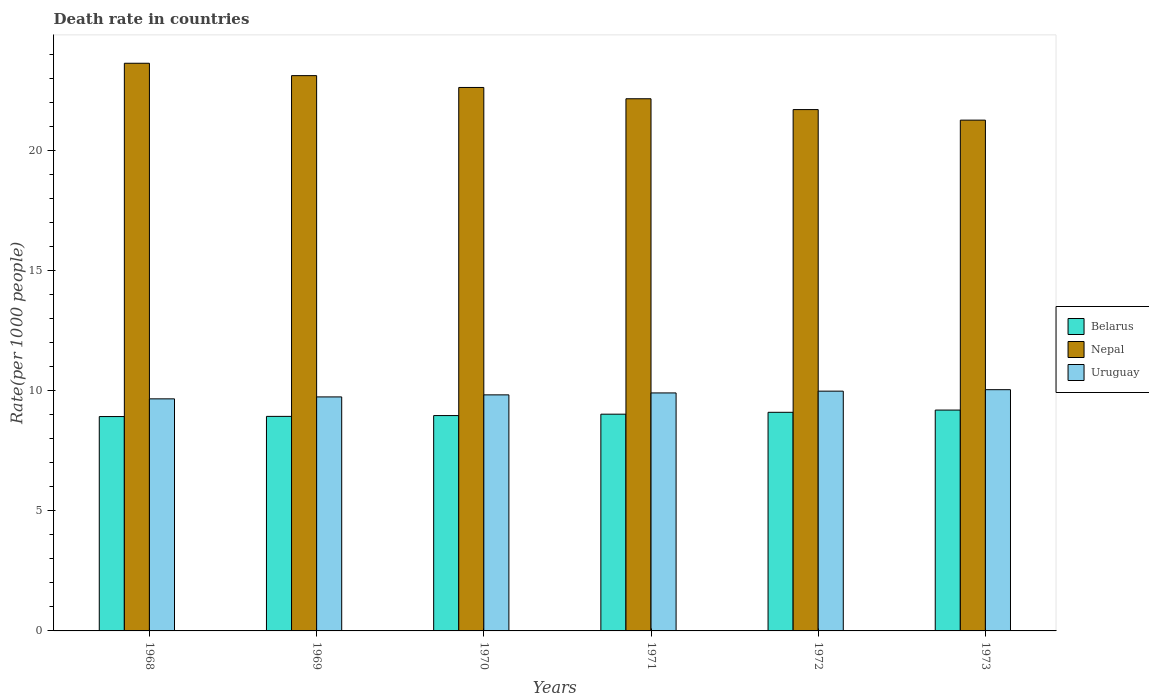Are the number of bars per tick equal to the number of legend labels?
Your answer should be compact. Yes. How many bars are there on the 6th tick from the right?
Make the answer very short. 3. What is the death rate in Nepal in 1968?
Offer a terse response. 23.64. Across all years, what is the maximum death rate in Nepal?
Offer a terse response. 23.64. Across all years, what is the minimum death rate in Uruguay?
Your answer should be very brief. 9.66. In which year was the death rate in Belarus maximum?
Keep it short and to the point. 1973. In which year was the death rate in Belarus minimum?
Provide a succinct answer. 1968. What is the total death rate in Nepal in the graph?
Provide a short and direct response. 134.52. What is the difference between the death rate in Nepal in 1969 and that in 1970?
Provide a short and direct response. 0.49. What is the difference between the death rate in Belarus in 1969 and the death rate in Nepal in 1972?
Give a very brief answer. -12.77. What is the average death rate in Uruguay per year?
Ensure brevity in your answer.  9.86. In the year 1969, what is the difference between the death rate in Belarus and death rate in Nepal?
Keep it short and to the point. -14.19. In how many years, is the death rate in Nepal greater than 5?
Your answer should be compact. 6. What is the ratio of the death rate in Uruguay in 1968 to that in 1970?
Your answer should be very brief. 0.98. Is the death rate in Uruguay in 1969 less than that in 1973?
Keep it short and to the point. Yes. Is the difference between the death rate in Belarus in 1970 and 1972 greater than the difference between the death rate in Nepal in 1970 and 1972?
Provide a succinct answer. No. What is the difference between the highest and the second highest death rate in Nepal?
Your answer should be very brief. 0.52. What is the difference between the highest and the lowest death rate in Nepal?
Offer a terse response. 2.37. In how many years, is the death rate in Uruguay greater than the average death rate in Uruguay taken over all years?
Make the answer very short. 3. What does the 3rd bar from the left in 1968 represents?
Keep it short and to the point. Uruguay. What does the 1st bar from the right in 1970 represents?
Ensure brevity in your answer.  Uruguay. Is it the case that in every year, the sum of the death rate in Belarus and death rate in Nepal is greater than the death rate in Uruguay?
Give a very brief answer. Yes. Are all the bars in the graph horizontal?
Give a very brief answer. No. How many years are there in the graph?
Keep it short and to the point. 6. What is the difference between two consecutive major ticks on the Y-axis?
Keep it short and to the point. 5. Are the values on the major ticks of Y-axis written in scientific E-notation?
Offer a terse response. No. Does the graph contain any zero values?
Provide a short and direct response. No. Does the graph contain grids?
Your answer should be very brief. No. How many legend labels are there?
Keep it short and to the point. 3. How are the legend labels stacked?
Make the answer very short. Vertical. What is the title of the graph?
Ensure brevity in your answer.  Death rate in countries. Does "Cambodia" appear as one of the legend labels in the graph?
Give a very brief answer. No. What is the label or title of the X-axis?
Provide a succinct answer. Years. What is the label or title of the Y-axis?
Your answer should be very brief. Rate(per 1000 people). What is the Rate(per 1000 people) of Belarus in 1968?
Your answer should be compact. 8.93. What is the Rate(per 1000 people) of Nepal in 1968?
Offer a very short reply. 23.64. What is the Rate(per 1000 people) in Uruguay in 1968?
Your answer should be very brief. 9.66. What is the Rate(per 1000 people) of Belarus in 1969?
Make the answer very short. 8.93. What is the Rate(per 1000 people) of Nepal in 1969?
Offer a very short reply. 23.12. What is the Rate(per 1000 people) in Uruguay in 1969?
Keep it short and to the point. 9.74. What is the Rate(per 1000 people) of Belarus in 1970?
Make the answer very short. 8.97. What is the Rate(per 1000 people) in Nepal in 1970?
Give a very brief answer. 22.63. What is the Rate(per 1000 people) of Uruguay in 1970?
Your answer should be compact. 9.83. What is the Rate(per 1000 people) of Belarus in 1971?
Ensure brevity in your answer.  9.03. What is the Rate(per 1000 people) of Nepal in 1971?
Keep it short and to the point. 22.16. What is the Rate(per 1000 people) of Uruguay in 1971?
Your answer should be compact. 9.91. What is the Rate(per 1000 people) in Belarus in 1972?
Your response must be concise. 9.1. What is the Rate(per 1000 people) of Nepal in 1972?
Offer a very short reply. 21.71. What is the Rate(per 1000 people) of Uruguay in 1972?
Offer a terse response. 9.98. What is the Rate(per 1000 people) of Belarus in 1973?
Your answer should be compact. 9.2. What is the Rate(per 1000 people) of Nepal in 1973?
Keep it short and to the point. 21.27. What is the Rate(per 1000 people) of Uruguay in 1973?
Make the answer very short. 10.04. Across all years, what is the maximum Rate(per 1000 people) of Belarus?
Ensure brevity in your answer.  9.2. Across all years, what is the maximum Rate(per 1000 people) in Nepal?
Ensure brevity in your answer.  23.64. Across all years, what is the maximum Rate(per 1000 people) in Uruguay?
Ensure brevity in your answer.  10.04. Across all years, what is the minimum Rate(per 1000 people) in Belarus?
Your answer should be compact. 8.93. Across all years, what is the minimum Rate(per 1000 people) in Nepal?
Ensure brevity in your answer.  21.27. Across all years, what is the minimum Rate(per 1000 people) of Uruguay?
Your answer should be compact. 9.66. What is the total Rate(per 1000 people) of Belarus in the graph?
Make the answer very short. 54.15. What is the total Rate(per 1000 people) of Nepal in the graph?
Ensure brevity in your answer.  134.52. What is the total Rate(per 1000 people) of Uruguay in the graph?
Offer a very short reply. 59.17. What is the difference between the Rate(per 1000 people) in Belarus in 1968 and that in 1969?
Ensure brevity in your answer.  -0.01. What is the difference between the Rate(per 1000 people) in Nepal in 1968 and that in 1969?
Your answer should be very brief. 0.52. What is the difference between the Rate(per 1000 people) of Uruguay in 1968 and that in 1969?
Your answer should be very brief. -0.08. What is the difference between the Rate(per 1000 people) of Belarus in 1968 and that in 1970?
Offer a very short reply. -0.04. What is the difference between the Rate(per 1000 people) in Uruguay in 1968 and that in 1970?
Keep it short and to the point. -0.17. What is the difference between the Rate(per 1000 people) in Belarus in 1968 and that in 1971?
Make the answer very short. -0.1. What is the difference between the Rate(per 1000 people) of Nepal in 1968 and that in 1971?
Your response must be concise. 1.48. What is the difference between the Rate(per 1000 people) of Uruguay in 1968 and that in 1971?
Offer a terse response. -0.25. What is the difference between the Rate(per 1000 people) in Belarus in 1968 and that in 1972?
Give a very brief answer. -0.18. What is the difference between the Rate(per 1000 people) in Nepal in 1968 and that in 1972?
Make the answer very short. 1.93. What is the difference between the Rate(per 1000 people) of Uruguay in 1968 and that in 1972?
Provide a short and direct response. -0.32. What is the difference between the Rate(per 1000 people) in Belarus in 1968 and that in 1973?
Provide a short and direct response. -0.27. What is the difference between the Rate(per 1000 people) of Nepal in 1968 and that in 1973?
Give a very brief answer. 2.37. What is the difference between the Rate(per 1000 people) in Uruguay in 1968 and that in 1973?
Provide a succinct answer. -0.38. What is the difference between the Rate(per 1000 people) in Belarus in 1969 and that in 1970?
Your response must be concise. -0.03. What is the difference between the Rate(per 1000 people) of Nepal in 1969 and that in 1970?
Keep it short and to the point. 0.49. What is the difference between the Rate(per 1000 people) in Uruguay in 1969 and that in 1970?
Make the answer very short. -0.09. What is the difference between the Rate(per 1000 people) of Belarus in 1969 and that in 1971?
Your answer should be compact. -0.09. What is the difference between the Rate(per 1000 people) of Uruguay in 1969 and that in 1971?
Provide a short and direct response. -0.17. What is the difference between the Rate(per 1000 people) in Belarus in 1969 and that in 1972?
Provide a short and direct response. -0.17. What is the difference between the Rate(per 1000 people) in Nepal in 1969 and that in 1972?
Your answer should be very brief. 1.41. What is the difference between the Rate(per 1000 people) in Uruguay in 1969 and that in 1972?
Give a very brief answer. -0.24. What is the difference between the Rate(per 1000 people) in Belarus in 1969 and that in 1973?
Make the answer very short. -0.26. What is the difference between the Rate(per 1000 people) in Nepal in 1969 and that in 1973?
Provide a short and direct response. 1.85. What is the difference between the Rate(per 1000 people) of Uruguay in 1969 and that in 1973?
Keep it short and to the point. -0.3. What is the difference between the Rate(per 1000 people) in Belarus in 1970 and that in 1971?
Your response must be concise. -0.06. What is the difference between the Rate(per 1000 people) of Nepal in 1970 and that in 1971?
Make the answer very short. 0.47. What is the difference between the Rate(per 1000 people) in Uruguay in 1970 and that in 1971?
Give a very brief answer. -0.08. What is the difference between the Rate(per 1000 people) of Belarus in 1970 and that in 1972?
Ensure brevity in your answer.  -0.14. What is the difference between the Rate(per 1000 people) of Nepal in 1970 and that in 1972?
Keep it short and to the point. 0.92. What is the difference between the Rate(per 1000 people) in Uruguay in 1970 and that in 1972?
Offer a very short reply. -0.15. What is the difference between the Rate(per 1000 people) of Belarus in 1970 and that in 1973?
Provide a short and direct response. -0.23. What is the difference between the Rate(per 1000 people) in Nepal in 1970 and that in 1973?
Give a very brief answer. 1.36. What is the difference between the Rate(per 1000 people) of Uruguay in 1970 and that in 1973?
Offer a very short reply. -0.22. What is the difference between the Rate(per 1000 people) of Belarus in 1971 and that in 1972?
Your response must be concise. -0.08. What is the difference between the Rate(per 1000 people) of Nepal in 1971 and that in 1972?
Make the answer very short. 0.45. What is the difference between the Rate(per 1000 people) of Uruguay in 1971 and that in 1972?
Your answer should be very brief. -0.07. What is the difference between the Rate(per 1000 people) in Belarus in 1971 and that in 1973?
Offer a very short reply. -0.17. What is the difference between the Rate(per 1000 people) in Nepal in 1971 and that in 1973?
Ensure brevity in your answer.  0.89. What is the difference between the Rate(per 1000 people) in Uruguay in 1971 and that in 1973?
Your answer should be very brief. -0.14. What is the difference between the Rate(per 1000 people) in Belarus in 1972 and that in 1973?
Your answer should be compact. -0.09. What is the difference between the Rate(per 1000 people) of Nepal in 1972 and that in 1973?
Offer a very short reply. 0.44. What is the difference between the Rate(per 1000 people) of Uruguay in 1972 and that in 1973?
Your answer should be compact. -0.06. What is the difference between the Rate(per 1000 people) in Belarus in 1968 and the Rate(per 1000 people) in Nepal in 1969?
Offer a terse response. -14.2. What is the difference between the Rate(per 1000 people) of Belarus in 1968 and the Rate(per 1000 people) of Uruguay in 1969?
Your response must be concise. -0.82. What is the difference between the Rate(per 1000 people) in Nepal in 1968 and the Rate(per 1000 people) in Uruguay in 1969?
Offer a very short reply. 13.89. What is the difference between the Rate(per 1000 people) of Belarus in 1968 and the Rate(per 1000 people) of Nepal in 1970?
Give a very brief answer. -13.7. What is the difference between the Rate(per 1000 people) in Belarus in 1968 and the Rate(per 1000 people) in Uruguay in 1970?
Ensure brevity in your answer.  -0.9. What is the difference between the Rate(per 1000 people) of Nepal in 1968 and the Rate(per 1000 people) of Uruguay in 1970?
Your answer should be very brief. 13.81. What is the difference between the Rate(per 1000 people) in Belarus in 1968 and the Rate(per 1000 people) in Nepal in 1971?
Your answer should be compact. -13.23. What is the difference between the Rate(per 1000 people) of Belarus in 1968 and the Rate(per 1000 people) of Uruguay in 1971?
Give a very brief answer. -0.98. What is the difference between the Rate(per 1000 people) of Nepal in 1968 and the Rate(per 1000 people) of Uruguay in 1971?
Provide a succinct answer. 13.73. What is the difference between the Rate(per 1000 people) in Belarus in 1968 and the Rate(per 1000 people) in Nepal in 1972?
Make the answer very short. -12.78. What is the difference between the Rate(per 1000 people) of Belarus in 1968 and the Rate(per 1000 people) of Uruguay in 1972?
Offer a very short reply. -1.06. What is the difference between the Rate(per 1000 people) in Nepal in 1968 and the Rate(per 1000 people) in Uruguay in 1972?
Offer a very short reply. 13.65. What is the difference between the Rate(per 1000 people) of Belarus in 1968 and the Rate(per 1000 people) of Nepal in 1973?
Keep it short and to the point. -12.34. What is the difference between the Rate(per 1000 people) of Belarus in 1968 and the Rate(per 1000 people) of Uruguay in 1973?
Give a very brief answer. -1.12. What is the difference between the Rate(per 1000 people) of Nepal in 1968 and the Rate(per 1000 people) of Uruguay in 1973?
Provide a short and direct response. 13.59. What is the difference between the Rate(per 1000 people) in Belarus in 1969 and the Rate(per 1000 people) in Nepal in 1970?
Offer a terse response. -13.7. What is the difference between the Rate(per 1000 people) in Belarus in 1969 and the Rate(per 1000 people) in Uruguay in 1970?
Your answer should be compact. -0.9. What is the difference between the Rate(per 1000 people) of Nepal in 1969 and the Rate(per 1000 people) of Uruguay in 1970?
Your answer should be compact. 13.29. What is the difference between the Rate(per 1000 people) of Belarus in 1969 and the Rate(per 1000 people) of Nepal in 1971?
Provide a short and direct response. -13.23. What is the difference between the Rate(per 1000 people) of Belarus in 1969 and the Rate(per 1000 people) of Uruguay in 1971?
Your answer should be very brief. -0.98. What is the difference between the Rate(per 1000 people) of Nepal in 1969 and the Rate(per 1000 people) of Uruguay in 1971?
Keep it short and to the point. 13.21. What is the difference between the Rate(per 1000 people) of Belarus in 1969 and the Rate(per 1000 people) of Nepal in 1972?
Make the answer very short. -12.78. What is the difference between the Rate(per 1000 people) in Belarus in 1969 and the Rate(per 1000 people) in Uruguay in 1972?
Ensure brevity in your answer.  -1.05. What is the difference between the Rate(per 1000 people) of Nepal in 1969 and the Rate(per 1000 people) of Uruguay in 1972?
Provide a short and direct response. 13.14. What is the difference between the Rate(per 1000 people) of Belarus in 1969 and the Rate(per 1000 people) of Nepal in 1973?
Your answer should be compact. -12.34. What is the difference between the Rate(per 1000 people) in Belarus in 1969 and the Rate(per 1000 people) in Uruguay in 1973?
Keep it short and to the point. -1.11. What is the difference between the Rate(per 1000 people) in Nepal in 1969 and the Rate(per 1000 people) in Uruguay in 1973?
Keep it short and to the point. 13.08. What is the difference between the Rate(per 1000 people) in Belarus in 1970 and the Rate(per 1000 people) in Nepal in 1971?
Your answer should be compact. -13.19. What is the difference between the Rate(per 1000 people) in Belarus in 1970 and the Rate(per 1000 people) in Uruguay in 1971?
Your answer should be compact. -0.94. What is the difference between the Rate(per 1000 people) in Nepal in 1970 and the Rate(per 1000 people) in Uruguay in 1971?
Keep it short and to the point. 12.72. What is the difference between the Rate(per 1000 people) in Belarus in 1970 and the Rate(per 1000 people) in Nepal in 1972?
Give a very brief answer. -12.74. What is the difference between the Rate(per 1000 people) of Belarus in 1970 and the Rate(per 1000 people) of Uruguay in 1972?
Your response must be concise. -1.02. What is the difference between the Rate(per 1000 people) of Nepal in 1970 and the Rate(per 1000 people) of Uruguay in 1972?
Offer a terse response. 12.64. What is the difference between the Rate(per 1000 people) in Belarus in 1970 and the Rate(per 1000 people) in Nepal in 1973?
Give a very brief answer. -12.3. What is the difference between the Rate(per 1000 people) of Belarus in 1970 and the Rate(per 1000 people) of Uruguay in 1973?
Your answer should be compact. -1.08. What is the difference between the Rate(per 1000 people) of Nepal in 1970 and the Rate(per 1000 people) of Uruguay in 1973?
Make the answer very short. 12.58. What is the difference between the Rate(per 1000 people) of Belarus in 1971 and the Rate(per 1000 people) of Nepal in 1972?
Ensure brevity in your answer.  -12.68. What is the difference between the Rate(per 1000 people) in Belarus in 1971 and the Rate(per 1000 people) in Uruguay in 1972?
Provide a succinct answer. -0.96. What is the difference between the Rate(per 1000 people) in Nepal in 1971 and the Rate(per 1000 people) in Uruguay in 1972?
Your answer should be compact. 12.18. What is the difference between the Rate(per 1000 people) in Belarus in 1971 and the Rate(per 1000 people) in Nepal in 1973?
Keep it short and to the point. -12.24. What is the difference between the Rate(per 1000 people) of Belarus in 1971 and the Rate(per 1000 people) of Uruguay in 1973?
Provide a succinct answer. -1.02. What is the difference between the Rate(per 1000 people) of Nepal in 1971 and the Rate(per 1000 people) of Uruguay in 1973?
Your answer should be very brief. 12.11. What is the difference between the Rate(per 1000 people) in Belarus in 1972 and the Rate(per 1000 people) in Nepal in 1973?
Give a very brief answer. -12.17. What is the difference between the Rate(per 1000 people) of Belarus in 1972 and the Rate(per 1000 people) of Uruguay in 1973?
Make the answer very short. -0.94. What is the difference between the Rate(per 1000 people) in Nepal in 1972 and the Rate(per 1000 people) in Uruguay in 1973?
Keep it short and to the point. 11.66. What is the average Rate(per 1000 people) of Belarus per year?
Your answer should be compact. 9.03. What is the average Rate(per 1000 people) in Nepal per year?
Give a very brief answer. 22.42. What is the average Rate(per 1000 people) of Uruguay per year?
Ensure brevity in your answer.  9.86. In the year 1968, what is the difference between the Rate(per 1000 people) of Belarus and Rate(per 1000 people) of Nepal?
Provide a short and direct response. -14.71. In the year 1968, what is the difference between the Rate(per 1000 people) in Belarus and Rate(per 1000 people) in Uruguay?
Your response must be concise. -0.74. In the year 1968, what is the difference between the Rate(per 1000 people) of Nepal and Rate(per 1000 people) of Uruguay?
Your answer should be very brief. 13.97. In the year 1969, what is the difference between the Rate(per 1000 people) of Belarus and Rate(per 1000 people) of Nepal?
Your answer should be compact. -14.19. In the year 1969, what is the difference between the Rate(per 1000 people) in Belarus and Rate(per 1000 people) in Uruguay?
Ensure brevity in your answer.  -0.81. In the year 1969, what is the difference between the Rate(per 1000 people) of Nepal and Rate(per 1000 people) of Uruguay?
Keep it short and to the point. 13.38. In the year 1970, what is the difference between the Rate(per 1000 people) in Belarus and Rate(per 1000 people) in Nepal?
Provide a succinct answer. -13.66. In the year 1970, what is the difference between the Rate(per 1000 people) of Belarus and Rate(per 1000 people) of Uruguay?
Provide a succinct answer. -0.86. In the year 1971, what is the difference between the Rate(per 1000 people) in Belarus and Rate(per 1000 people) in Nepal?
Your answer should be compact. -13.13. In the year 1971, what is the difference between the Rate(per 1000 people) in Belarus and Rate(per 1000 people) in Uruguay?
Ensure brevity in your answer.  -0.89. In the year 1971, what is the difference between the Rate(per 1000 people) in Nepal and Rate(per 1000 people) in Uruguay?
Offer a very short reply. 12.25. In the year 1972, what is the difference between the Rate(per 1000 people) in Belarus and Rate(per 1000 people) in Nepal?
Keep it short and to the point. -12.61. In the year 1972, what is the difference between the Rate(per 1000 people) in Belarus and Rate(per 1000 people) in Uruguay?
Offer a very short reply. -0.88. In the year 1972, what is the difference between the Rate(per 1000 people) in Nepal and Rate(per 1000 people) in Uruguay?
Ensure brevity in your answer.  11.72. In the year 1973, what is the difference between the Rate(per 1000 people) in Belarus and Rate(per 1000 people) in Nepal?
Make the answer very short. -12.07. In the year 1973, what is the difference between the Rate(per 1000 people) of Belarus and Rate(per 1000 people) of Uruguay?
Your answer should be compact. -0.85. In the year 1973, what is the difference between the Rate(per 1000 people) in Nepal and Rate(per 1000 people) in Uruguay?
Keep it short and to the point. 11.22. What is the ratio of the Rate(per 1000 people) in Belarus in 1968 to that in 1969?
Make the answer very short. 1. What is the ratio of the Rate(per 1000 people) in Nepal in 1968 to that in 1969?
Provide a short and direct response. 1.02. What is the ratio of the Rate(per 1000 people) in Uruguay in 1968 to that in 1969?
Keep it short and to the point. 0.99. What is the ratio of the Rate(per 1000 people) of Nepal in 1968 to that in 1970?
Your answer should be compact. 1.04. What is the ratio of the Rate(per 1000 people) of Uruguay in 1968 to that in 1970?
Offer a very short reply. 0.98. What is the ratio of the Rate(per 1000 people) of Nepal in 1968 to that in 1971?
Give a very brief answer. 1.07. What is the ratio of the Rate(per 1000 people) in Uruguay in 1968 to that in 1971?
Ensure brevity in your answer.  0.98. What is the ratio of the Rate(per 1000 people) in Belarus in 1968 to that in 1972?
Your answer should be compact. 0.98. What is the ratio of the Rate(per 1000 people) in Nepal in 1968 to that in 1972?
Give a very brief answer. 1.09. What is the ratio of the Rate(per 1000 people) in Uruguay in 1968 to that in 1972?
Give a very brief answer. 0.97. What is the ratio of the Rate(per 1000 people) in Belarus in 1968 to that in 1973?
Make the answer very short. 0.97. What is the ratio of the Rate(per 1000 people) in Nepal in 1968 to that in 1973?
Keep it short and to the point. 1.11. What is the ratio of the Rate(per 1000 people) in Uruguay in 1968 to that in 1973?
Offer a very short reply. 0.96. What is the ratio of the Rate(per 1000 people) of Nepal in 1969 to that in 1970?
Provide a succinct answer. 1.02. What is the ratio of the Rate(per 1000 people) of Uruguay in 1969 to that in 1970?
Provide a short and direct response. 0.99. What is the ratio of the Rate(per 1000 people) in Nepal in 1969 to that in 1971?
Make the answer very short. 1.04. What is the ratio of the Rate(per 1000 people) in Uruguay in 1969 to that in 1971?
Give a very brief answer. 0.98. What is the ratio of the Rate(per 1000 people) in Belarus in 1969 to that in 1972?
Keep it short and to the point. 0.98. What is the ratio of the Rate(per 1000 people) of Nepal in 1969 to that in 1972?
Give a very brief answer. 1.07. What is the ratio of the Rate(per 1000 people) of Uruguay in 1969 to that in 1972?
Offer a terse response. 0.98. What is the ratio of the Rate(per 1000 people) of Belarus in 1969 to that in 1973?
Offer a terse response. 0.97. What is the ratio of the Rate(per 1000 people) in Nepal in 1969 to that in 1973?
Keep it short and to the point. 1.09. What is the ratio of the Rate(per 1000 people) in Uruguay in 1969 to that in 1973?
Your answer should be very brief. 0.97. What is the ratio of the Rate(per 1000 people) of Nepal in 1970 to that in 1971?
Your response must be concise. 1.02. What is the ratio of the Rate(per 1000 people) of Uruguay in 1970 to that in 1971?
Provide a succinct answer. 0.99. What is the ratio of the Rate(per 1000 people) of Belarus in 1970 to that in 1972?
Give a very brief answer. 0.99. What is the ratio of the Rate(per 1000 people) in Nepal in 1970 to that in 1972?
Your answer should be compact. 1.04. What is the ratio of the Rate(per 1000 people) of Uruguay in 1970 to that in 1972?
Offer a very short reply. 0.98. What is the ratio of the Rate(per 1000 people) of Belarus in 1970 to that in 1973?
Make the answer very short. 0.98. What is the ratio of the Rate(per 1000 people) of Nepal in 1970 to that in 1973?
Offer a very short reply. 1.06. What is the ratio of the Rate(per 1000 people) of Uruguay in 1970 to that in 1973?
Your response must be concise. 0.98. What is the ratio of the Rate(per 1000 people) of Nepal in 1971 to that in 1972?
Offer a terse response. 1.02. What is the ratio of the Rate(per 1000 people) of Belarus in 1971 to that in 1973?
Offer a very short reply. 0.98. What is the ratio of the Rate(per 1000 people) of Nepal in 1971 to that in 1973?
Give a very brief answer. 1.04. What is the ratio of the Rate(per 1000 people) in Uruguay in 1971 to that in 1973?
Make the answer very short. 0.99. What is the ratio of the Rate(per 1000 people) of Nepal in 1972 to that in 1973?
Your answer should be compact. 1.02. What is the difference between the highest and the second highest Rate(per 1000 people) of Belarus?
Give a very brief answer. 0.09. What is the difference between the highest and the second highest Rate(per 1000 people) of Nepal?
Provide a short and direct response. 0.52. What is the difference between the highest and the second highest Rate(per 1000 people) in Uruguay?
Your answer should be compact. 0.06. What is the difference between the highest and the lowest Rate(per 1000 people) in Belarus?
Your response must be concise. 0.27. What is the difference between the highest and the lowest Rate(per 1000 people) in Nepal?
Ensure brevity in your answer.  2.37. What is the difference between the highest and the lowest Rate(per 1000 people) in Uruguay?
Give a very brief answer. 0.38. 